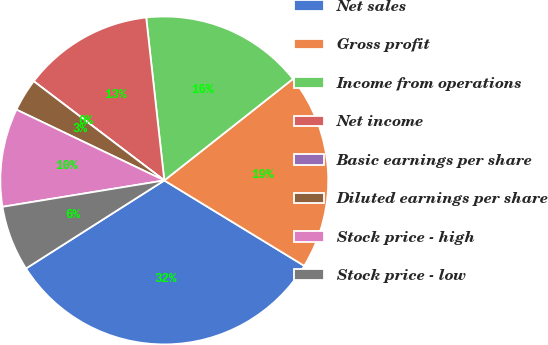<chart> <loc_0><loc_0><loc_500><loc_500><pie_chart><fcel>Net sales<fcel>Gross profit<fcel>Income from operations<fcel>Net income<fcel>Basic earnings per share<fcel>Diluted earnings per share<fcel>Stock price - high<fcel>Stock price - low<nl><fcel>32.26%<fcel>19.35%<fcel>16.13%<fcel>12.9%<fcel>0.0%<fcel>3.23%<fcel>9.68%<fcel>6.45%<nl></chart> 